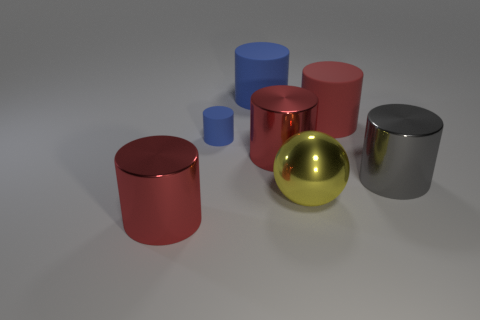There is a small object that is the same shape as the big red matte object; what is its color?
Keep it short and to the point. Blue. There is a gray metallic thing that is the same shape as the big blue thing; what is its size?
Keep it short and to the point. Large. How many large things have the same color as the tiny cylinder?
Your answer should be very brief. 1. What number of objects are big red cylinders behind the large gray metal object or large red things right of the large ball?
Your response must be concise. 2. Are there fewer large yellow balls to the right of the big gray cylinder than big blue things?
Give a very brief answer. Yes. Are there any red things that have the same size as the gray object?
Your response must be concise. Yes. What color is the big shiny sphere?
Give a very brief answer. Yellow. Is the gray metal object the same size as the yellow object?
Provide a short and direct response. Yes. How many things are small blue rubber things or yellow shiny spheres?
Make the answer very short. 2. Is the number of objects in front of the yellow thing the same as the number of tiny red shiny balls?
Ensure brevity in your answer.  No. 